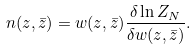Convert formula to latex. <formula><loc_0><loc_0><loc_500><loc_500>n ( z , \bar { z } ) = w ( z , \bar { z } ) \frac { \delta \ln Z _ { N } } { \delta w ( z , \bar { z } ) } .</formula> 